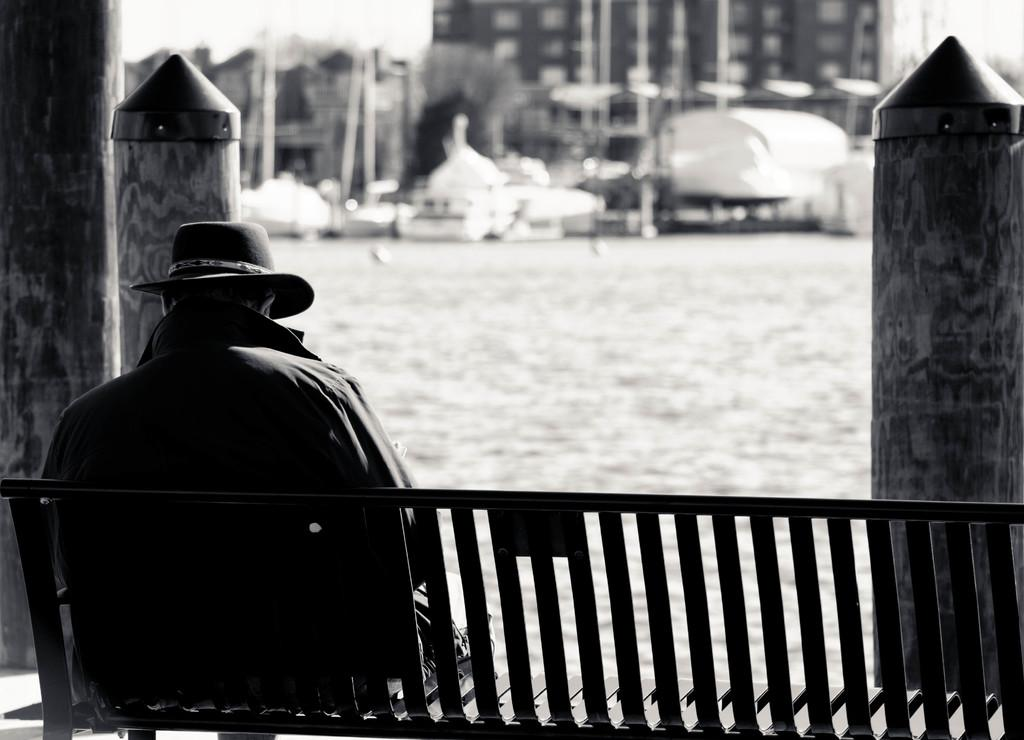What is the color scheme of the image? The image is black and white. What is the person in the image doing? The person is sitting on a bench in the image. What objects can be seen in the image besides the person? There are poles visible in the image. What can be seen in the background of the image? The background of the image is blurry, but there are buildings visible in the background. What type of reaction does the actor have to the copy in the image? There is no actor, copy, or reaction present in the image; it features a person sitting on a bench with poles and blurry buildings in the background. 